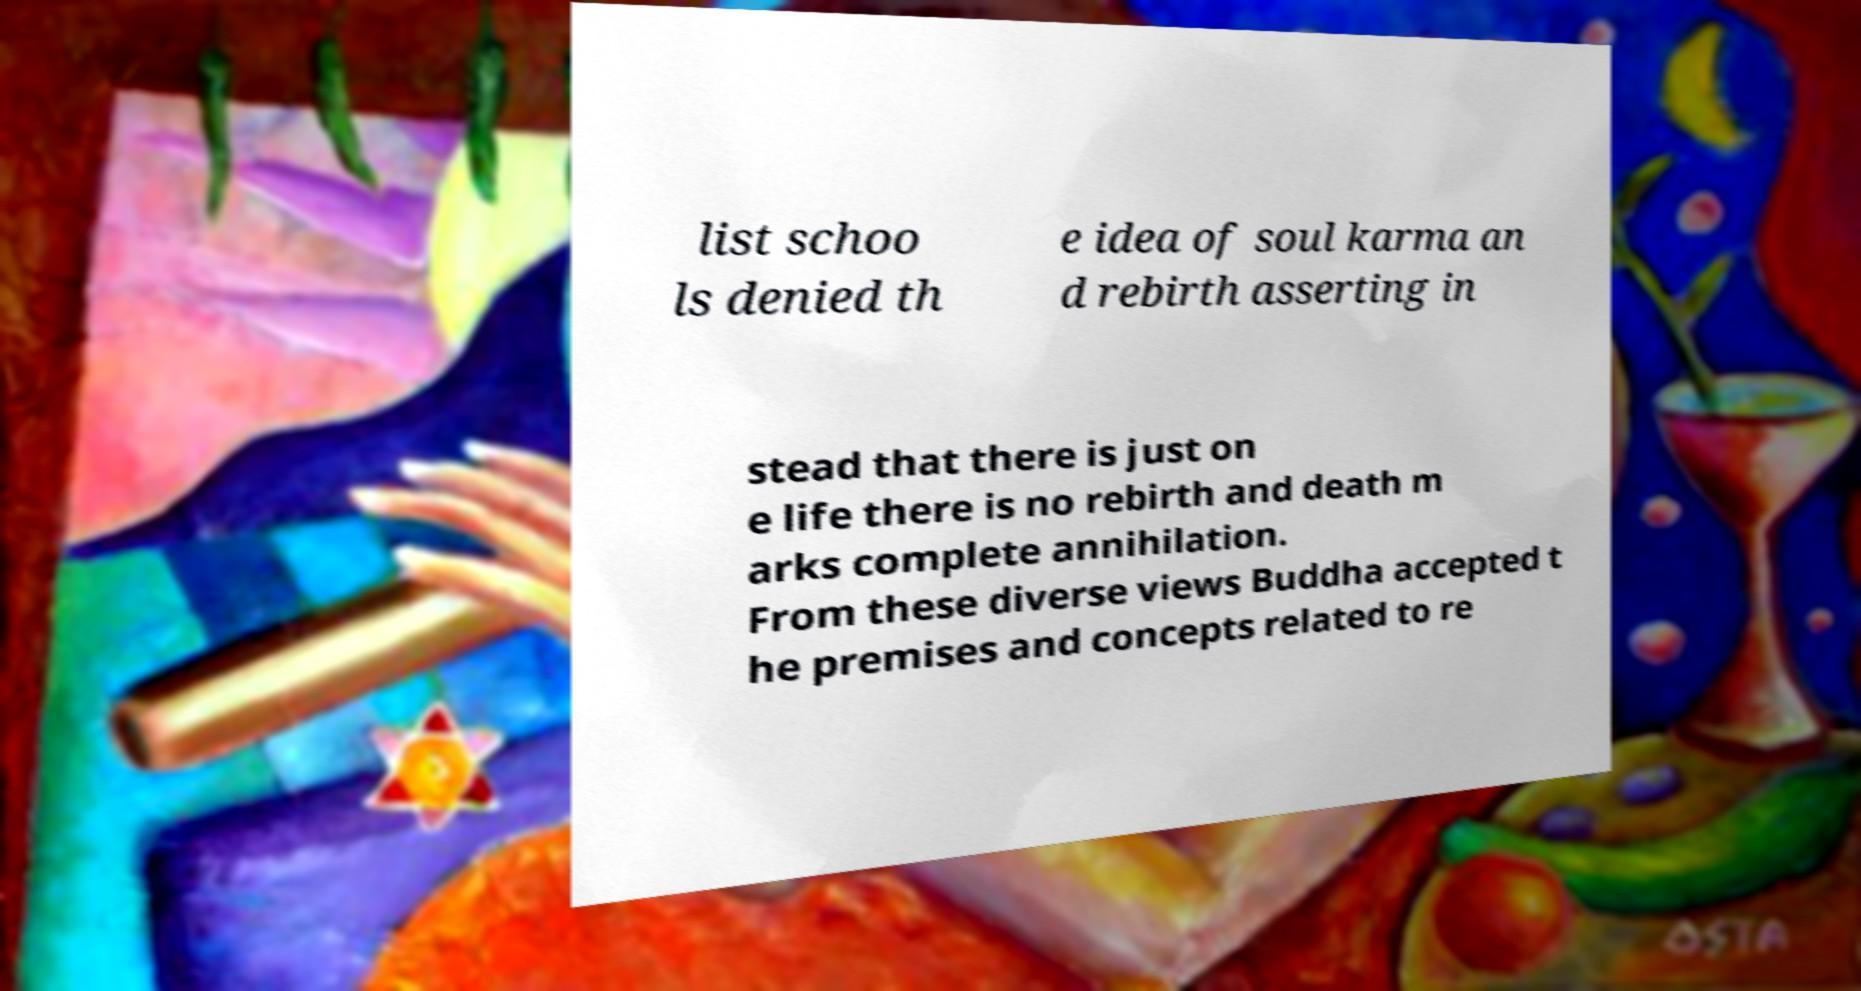Please identify and transcribe the text found in this image. list schoo ls denied th e idea of soul karma an d rebirth asserting in stead that there is just on e life there is no rebirth and death m arks complete annihilation. From these diverse views Buddha accepted t he premises and concepts related to re 